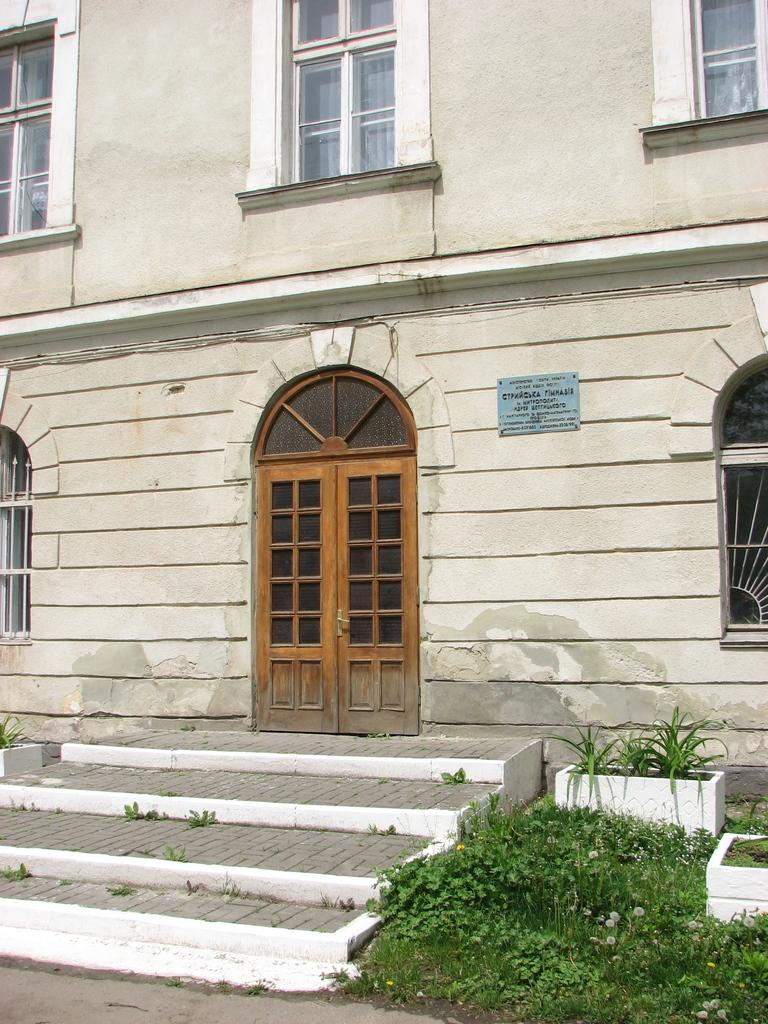What type of vegetation can be seen in the image? There is grass in the image. What other plants are visible in the image? There are house plants in the image. Are there any architectural features in the image? Yes, there are steps in the image. What part of the building can be seen in the image? There is a door and windows in the image. What type of structure is present in the image? There is a building in the image. What type of muscle is being exercised by the daughter in the image? There is no daughter present in the image, and therefore no muscle exercise can be observed. 